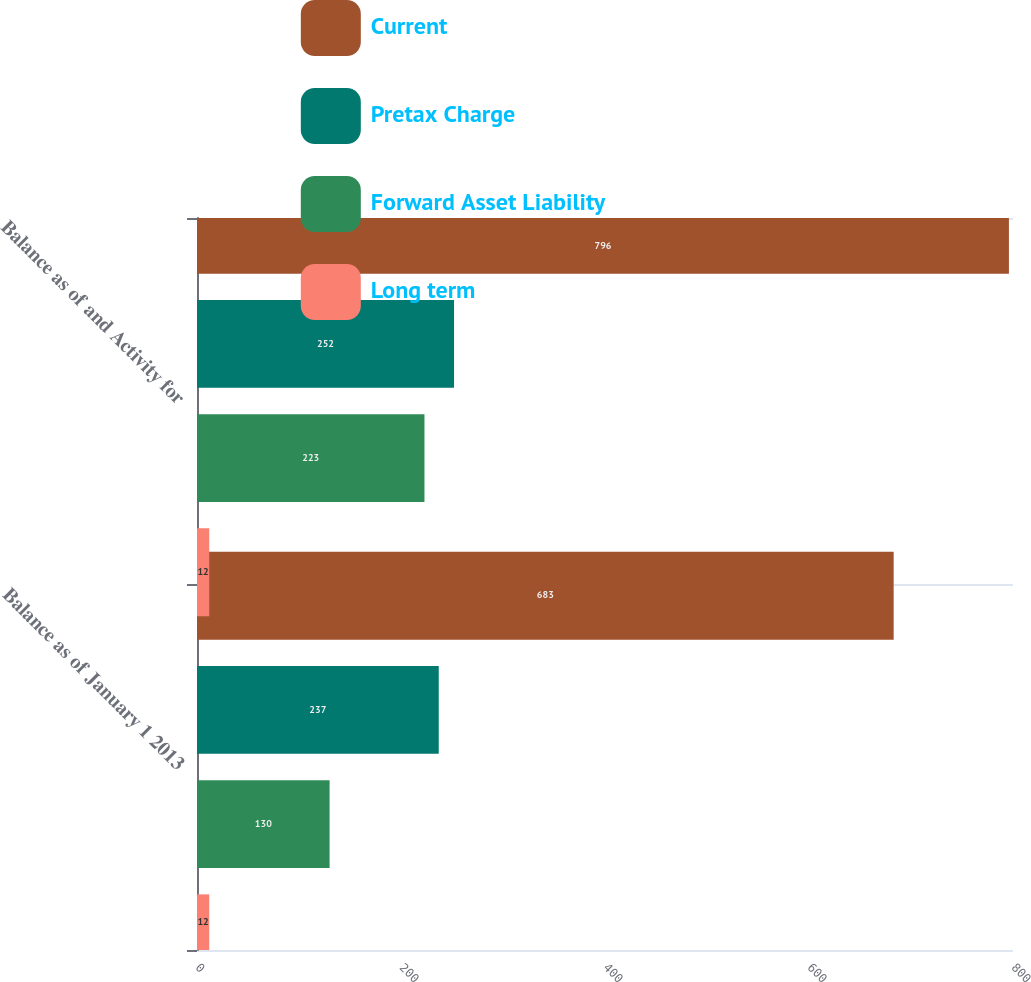Convert chart. <chart><loc_0><loc_0><loc_500><loc_500><stacked_bar_chart><ecel><fcel>Balance as of January 1 2013<fcel>Balance as of and Activity for<nl><fcel>Current<fcel>683<fcel>796<nl><fcel>Pretax Charge<fcel>237<fcel>252<nl><fcel>Forward Asset Liability<fcel>130<fcel>223<nl><fcel>Long term<fcel>12<fcel>12<nl></chart> 